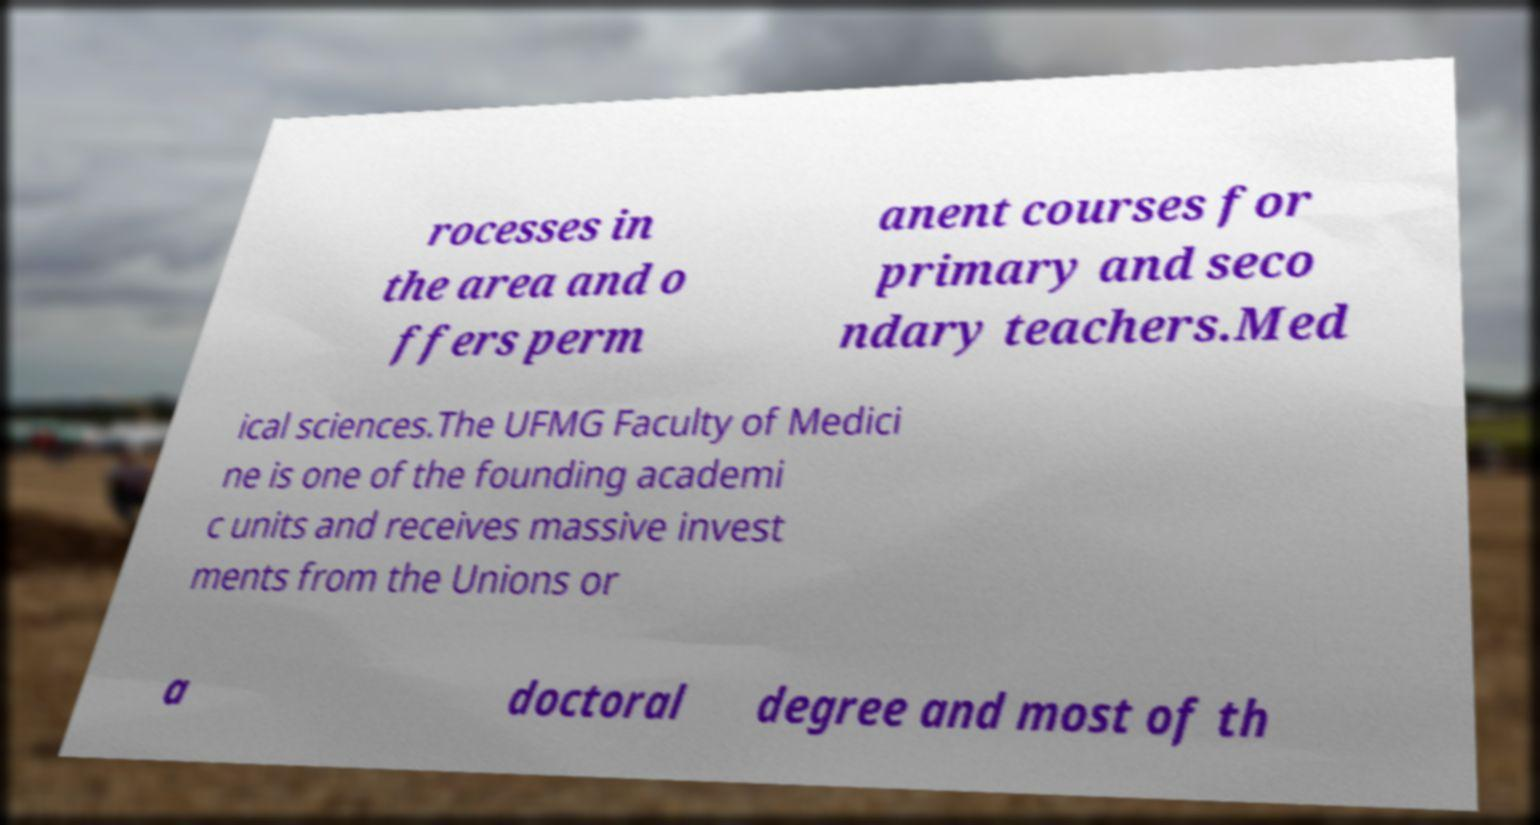What messages or text are displayed in this image? I need them in a readable, typed format. rocesses in the area and o ffers perm anent courses for primary and seco ndary teachers.Med ical sciences.The UFMG Faculty of Medici ne is one of the founding academi c units and receives massive invest ments from the Unions or a doctoral degree and most of th 